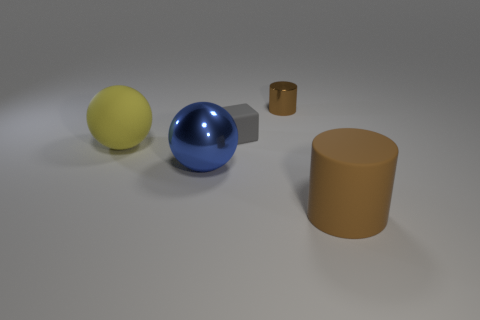Subtract all spheres. How many objects are left? 3 Add 4 big shiny objects. How many big shiny objects are left? 5 Add 5 tiny cylinders. How many tiny cylinders exist? 6 Add 5 metal objects. How many objects exist? 10 Subtract 0 yellow cubes. How many objects are left? 5 Subtract all yellow balls. Subtract all brown blocks. How many balls are left? 1 Subtract all gray cubes. How many blue cylinders are left? 0 Subtract all large purple metal blocks. Subtract all yellow matte things. How many objects are left? 4 